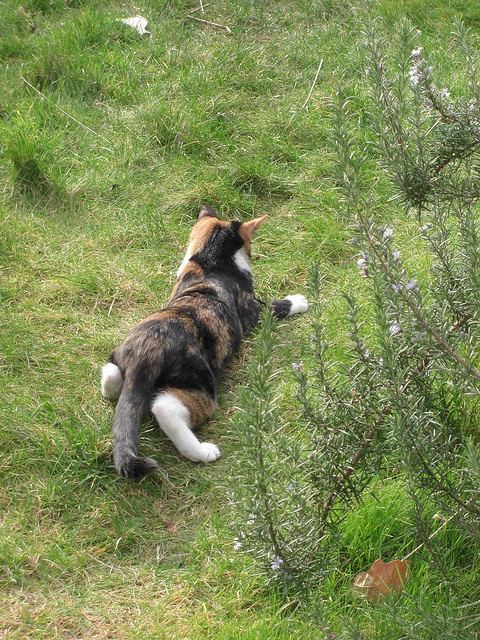Describe the objects in this image and their specific colors. I can see a cat in olive, black, gray, darkgray, and lightgray tones in this image. 